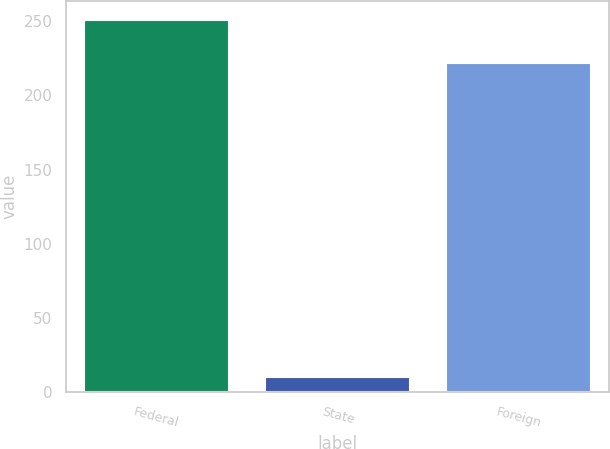Convert chart to OTSL. <chart><loc_0><loc_0><loc_500><loc_500><bar_chart><fcel>Federal<fcel>State<fcel>Foreign<nl><fcel>251<fcel>10<fcel>222<nl></chart> 